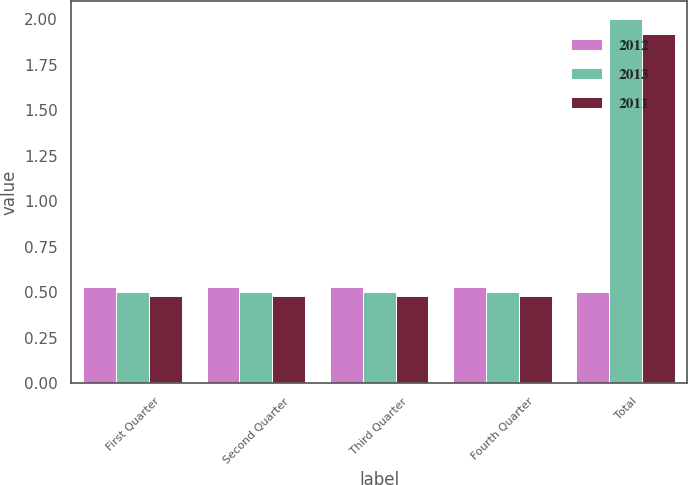Convert chart to OTSL. <chart><loc_0><loc_0><loc_500><loc_500><stacked_bar_chart><ecel><fcel>First Quarter<fcel>Second Quarter<fcel>Third Quarter<fcel>Fourth Quarter<fcel>Total<nl><fcel>2012<fcel>0.53<fcel>0.53<fcel>0.53<fcel>0.53<fcel>0.5<nl><fcel>2013<fcel>0.5<fcel>0.5<fcel>0.5<fcel>0.5<fcel>2<nl><fcel>2011<fcel>0.48<fcel>0.48<fcel>0.48<fcel>0.48<fcel>1.92<nl></chart> 